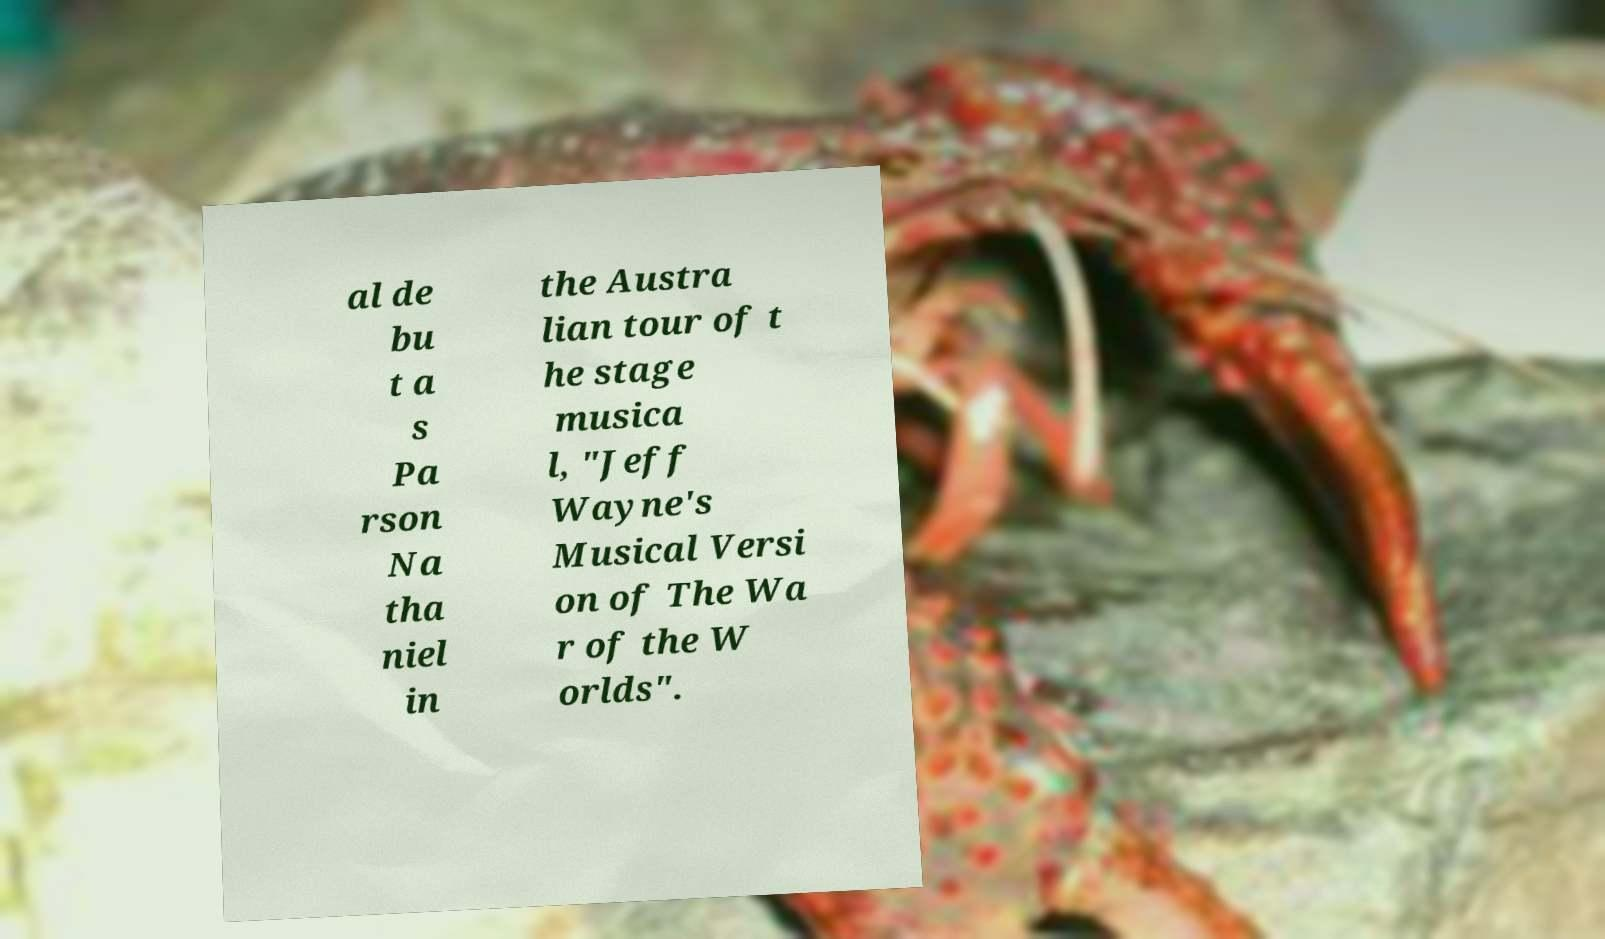Please identify and transcribe the text found in this image. al de bu t a s Pa rson Na tha niel in the Austra lian tour of t he stage musica l, "Jeff Wayne's Musical Versi on of The Wa r of the W orlds". 